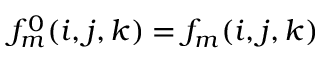<formula> <loc_0><loc_0><loc_500><loc_500>f _ { m } ^ { 0 } ( i , j , k ) = f _ { m } ( i , j , k )</formula> 